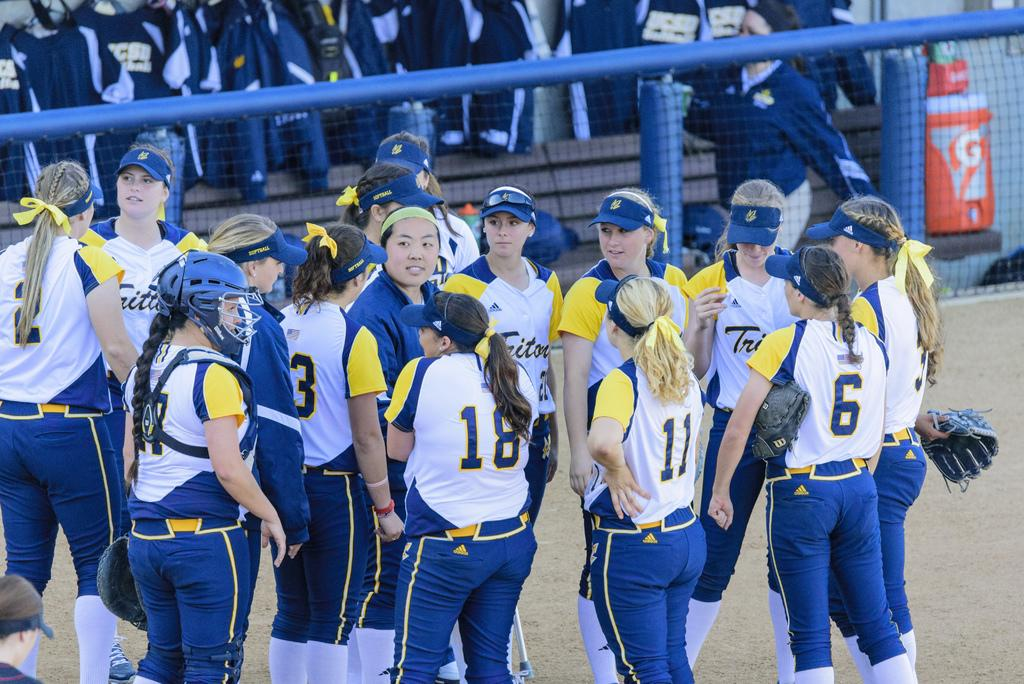Provide a one-sentence caption for the provided image. A group of female athletes, 18 11 and 6 are in the center. 